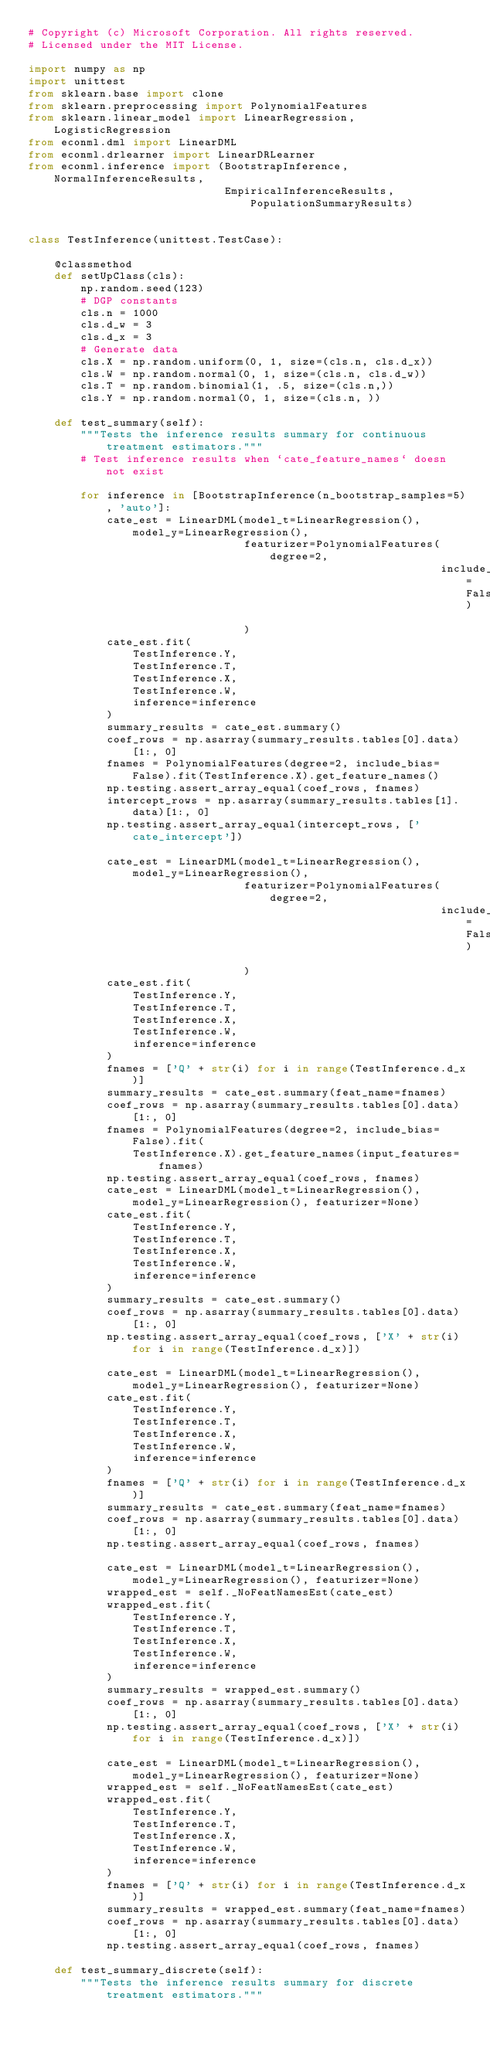Convert code to text. <code><loc_0><loc_0><loc_500><loc_500><_Python_># Copyright (c) Microsoft Corporation. All rights reserved.
# Licensed under the MIT License.

import numpy as np
import unittest
from sklearn.base import clone
from sklearn.preprocessing import PolynomialFeatures
from sklearn.linear_model import LinearRegression, LogisticRegression
from econml.dml import LinearDML
from econml.drlearner import LinearDRLearner
from econml.inference import (BootstrapInference, NormalInferenceResults,
                              EmpiricalInferenceResults, PopulationSummaryResults)


class TestInference(unittest.TestCase):

    @classmethod
    def setUpClass(cls):
        np.random.seed(123)
        # DGP constants
        cls.n = 1000
        cls.d_w = 3
        cls.d_x = 3
        # Generate data
        cls.X = np.random.uniform(0, 1, size=(cls.n, cls.d_x))
        cls.W = np.random.normal(0, 1, size=(cls.n, cls.d_w))
        cls.T = np.random.binomial(1, .5, size=(cls.n,))
        cls.Y = np.random.normal(0, 1, size=(cls.n, ))

    def test_summary(self):
        """Tests the inference results summary for continuous treatment estimators."""
        # Test inference results when `cate_feature_names` doesn not exist

        for inference in [BootstrapInference(n_bootstrap_samples=5), 'auto']:
            cate_est = LinearDML(model_t=LinearRegression(), model_y=LinearRegression(),
                                 featurizer=PolynomialFeatures(degree=2,
                                                               include_bias=False)
                                 )
            cate_est.fit(
                TestInference.Y,
                TestInference.T,
                TestInference.X,
                TestInference.W,
                inference=inference
            )
            summary_results = cate_est.summary()
            coef_rows = np.asarray(summary_results.tables[0].data)[1:, 0]
            fnames = PolynomialFeatures(degree=2, include_bias=False).fit(TestInference.X).get_feature_names()
            np.testing.assert_array_equal(coef_rows, fnames)
            intercept_rows = np.asarray(summary_results.tables[1].data)[1:, 0]
            np.testing.assert_array_equal(intercept_rows, ['cate_intercept'])

            cate_est = LinearDML(model_t=LinearRegression(), model_y=LinearRegression(),
                                 featurizer=PolynomialFeatures(degree=2,
                                                               include_bias=False)
                                 )
            cate_est.fit(
                TestInference.Y,
                TestInference.T,
                TestInference.X,
                TestInference.W,
                inference=inference
            )
            fnames = ['Q' + str(i) for i in range(TestInference.d_x)]
            summary_results = cate_est.summary(feat_name=fnames)
            coef_rows = np.asarray(summary_results.tables[0].data)[1:, 0]
            fnames = PolynomialFeatures(degree=2, include_bias=False).fit(
                TestInference.X).get_feature_names(input_features=fnames)
            np.testing.assert_array_equal(coef_rows, fnames)
            cate_est = LinearDML(model_t=LinearRegression(), model_y=LinearRegression(), featurizer=None)
            cate_est.fit(
                TestInference.Y,
                TestInference.T,
                TestInference.X,
                TestInference.W,
                inference=inference
            )
            summary_results = cate_est.summary()
            coef_rows = np.asarray(summary_results.tables[0].data)[1:, 0]
            np.testing.assert_array_equal(coef_rows, ['X' + str(i) for i in range(TestInference.d_x)])

            cate_est = LinearDML(model_t=LinearRegression(), model_y=LinearRegression(), featurizer=None)
            cate_est.fit(
                TestInference.Y,
                TestInference.T,
                TestInference.X,
                TestInference.W,
                inference=inference
            )
            fnames = ['Q' + str(i) for i in range(TestInference.d_x)]
            summary_results = cate_est.summary(feat_name=fnames)
            coef_rows = np.asarray(summary_results.tables[0].data)[1:, 0]
            np.testing.assert_array_equal(coef_rows, fnames)

            cate_est = LinearDML(model_t=LinearRegression(), model_y=LinearRegression(), featurizer=None)
            wrapped_est = self._NoFeatNamesEst(cate_est)
            wrapped_est.fit(
                TestInference.Y,
                TestInference.T,
                TestInference.X,
                TestInference.W,
                inference=inference
            )
            summary_results = wrapped_est.summary()
            coef_rows = np.asarray(summary_results.tables[0].data)[1:, 0]
            np.testing.assert_array_equal(coef_rows, ['X' + str(i) for i in range(TestInference.d_x)])

            cate_est = LinearDML(model_t=LinearRegression(), model_y=LinearRegression(), featurizer=None)
            wrapped_est = self._NoFeatNamesEst(cate_est)
            wrapped_est.fit(
                TestInference.Y,
                TestInference.T,
                TestInference.X,
                TestInference.W,
                inference=inference
            )
            fnames = ['Q' + str(i) for i in range(TestInference.d_x)]
            summary_results = wrapped_est.summary(feat_name=fnames)
            coef_rows = np.asarray(summary_results.tables[0].data)[1:, 0]
            np.testing.assert_array_equal(coef_rows, fnames)

    def test_summary_discrete(self):
        """Tests the inference results summary for discrete treatment estimators."""</code> 